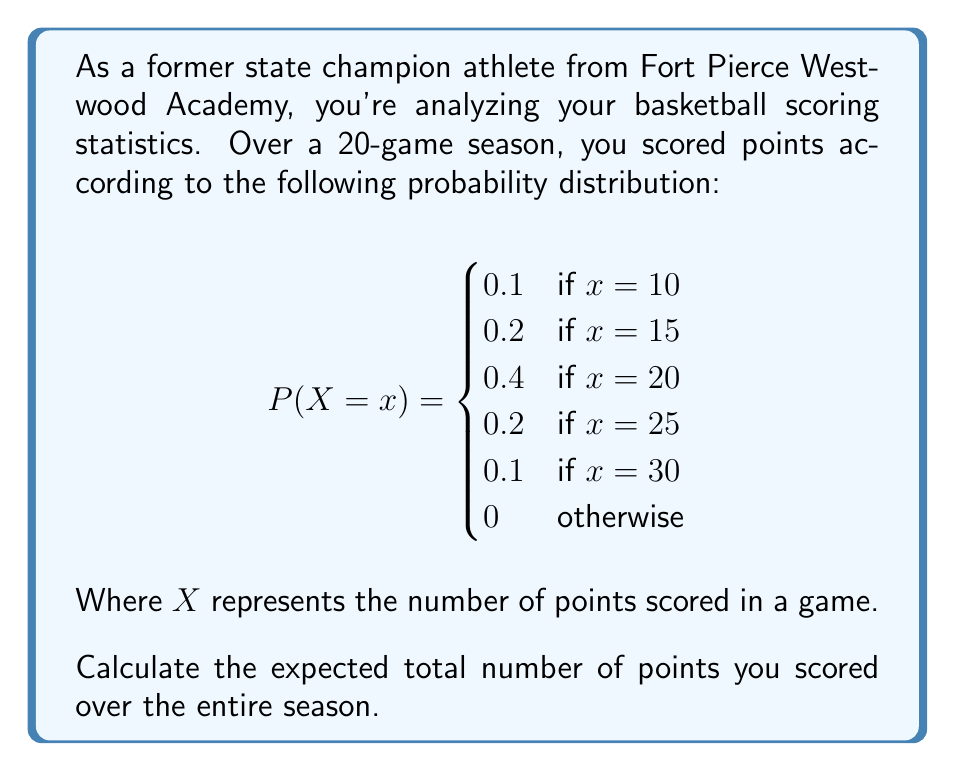Provide a solution to this math problem. To solve this problem, we'll follow these steps:

1) First, let's calculate the expected value (mean) of points scored in a single game:

   $$E(X) = \sum_{x} x \cdot P(X=x)$$

2) Substituting the values from the given probability distribution:

   $$E(X) = 10 \cdot 0.1 + 15 \cdot 0.2 + 20 \cdot 0.4 + 25 \cdot 0.2 + 30 \cdot 0.1$$

3) Calculating:

   $$E(X) = 1 + 3 + 8 + 5 + 3 = 20$$

4) So, on average, you scored 20 points per game.

5) To find the expected total number of points over the entire season, we multiply the expected points per game by the number of games:

   $$\text{Expected Total} = E(X) \cdot \text{Number of Games}$$
   $$\text{Expected Total} = 20 \cdot 20 = 400$$

Therefore, the expected total number of points scored over the 20-game season is 400 points.
Answer: 400 points 